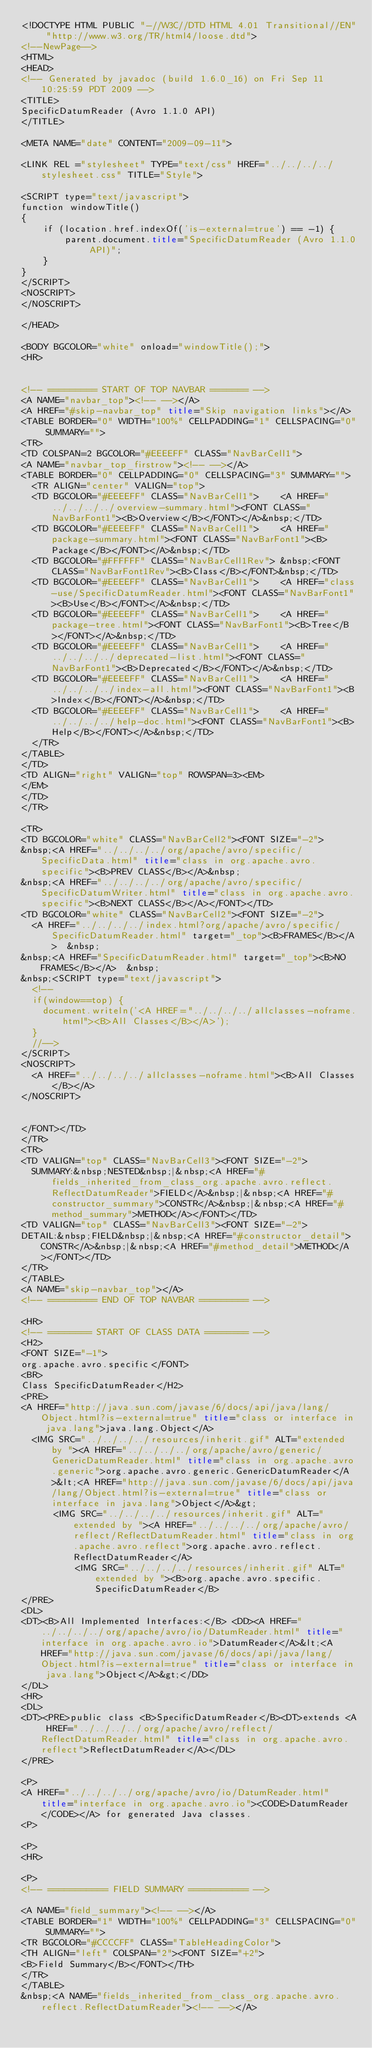<code> <loc_0><loc_0><loc_500><loc_500><_HTML_><!DOCTYPE HTML PUBLIC "-//W3C//DTD HTML 4.01 Transitional//EN" "http://www.w3.org/TR/html4/loose.dtd">
<!--NewPage-->
<HTML>
<HEAD>
<!-- Generated by javadoc (build 1.6.0_16) on Fri Sep 11 10:25:59 PDT 2009 -->
<TITLE>
SpecificDatumReader (Avro 1.1.0 API)
</TITLE>

<META NAME="date" CONTENT="2009-09-11">

<LINK REL ="stylesheet" TYPE="text/css" HREF="../../../../stylesheet.css" TITLE="Style">

<SCRIPT type="text/javascript">
function windowTitle()
{
    if (location.href.indexOf('is-external=true') == -1) {
        parent.document.title="SpecificDatumReader (Avro 1.1.0 API)";
    }
}
</SCRIPT>
<NOSCRIPT>
</NOSCRIPT>

</HEAD>

<BODY BGCOLOR="white" onload="windowTitle();">
<HR>


<!-- ========= START OF TOP NAVBAR ======= -->
<A NAME="navbar_top"><!-- --></A>
<A HREF="#skip-navbar_top" title="Skip navigation links"></A>
<TABLE BORDER="0" WIDTH="100%" CELLPADDING="1" CELLSPACING="0" SUMMARY="">
<TR>
<TD COLSPAN=2 BGCOLOR="#EEEEFF" CLASS="NavBarCell1">
<A NAME="navbar_top_firstrow"><!-- --></A>
<TABLE BORDER="0" CELLPADDING="0" CELLSPACING="3" SUMMARY="">
  <TR ALIGN="center" VALIGN="top">
  <TD BGCOLOR="#EEEEFF" CLASS="NavBarCell1">    <A HREF="../../../../overview-summary.html"><FONT CLASS="NavBarFont1"><B>Overview</B></FONT></A>&nbsp;</TD>
  <TD BGCOLOR="#EEEEFF" CLASS="NavBarCell1">    <A HREF="package-summary.html"><FONT CLASS="NavBarFont1"><B>Package</B></FONT></A>&nbsp;</TD>
  <TD BGCOLOR="#FFFFFF" CLASS="NavBarCell1Rev"> &nbsp;<FONT CLASS="NavBarFont1Rev"><B>Class</B></FONT>&nbsp;</TD>
  <TD BGCOLOR="#EEEEFF" CLASS="NavBarCell1">    <A HREF="class-use/SpecificDatumReader.html"><FONT CLASS="NavBarFont1"><B>Use</B></FONT></A>&nbsp;</TD>
  <TD BGCOLOR="#EEEEFF" CLASS="NavBarCell1">    <A HREF="package-tree.html"><FONT CLASS="NavBarFont1"><B>Tree</B></FONT></A>&nbsp;</TD>
  <TD BGCOLOR="#EEEEFF" CLASS="NavBarCell1">    <A HREF="../../../../deprecated-list.html"><FONT CLASS="NavBarFont1"><B>Deprecated</B></FONT></A>&nbsp;</TD>
  <TD BGCOLOR="#EEEEFF" CLASS="NavBarCell1">    <A HREF="../../../../index-all.html"><FONT CLASS="NavBarFont1"><B>Index</B></FONT></A>&nbsp;</TD>
  <TD BGCOLOR="#EEEEFF" CLASS="NavBarCell1">    <A HREF="../../../../help-doc.html"><FONT CLASS="NavBarFont1"><B>Help</B></FONT></A>&nbsp;</TD>
  </TR>
</TABLE>
</TD>
<TD ALIGN="right" VALIGN="top" ROWSPAN=3><EM>
</EM>
</TD>
</TR>

<TR>
<TD BGCOLOR="white" CLASS="NavBarCell2"><FONT SIZE="-2">
&nbsp;<A HREF="../../../../org/apache/avro/specific/SpecificData.html" title="class in org.apache.avro.specific"><B>PREV CLASS</B></A>&nbsp;
&nbsp;<A HREF="../../../../org/apache/avro/specific/SpecificDatumWriter.html" title="class in org.apache.avro.specific"><B>NEXT CLASS</B></A></FONT></TD>
<TD BGCOLOR="white" CLASS="NavBarCell2"><FONT SIZE="-2">
  <A HREF="../../../../index.html?org/apache/avro/specific/SpecificDatumReader.html" target="_top"><B>FRAMES</B></A>  &nbsp;
&nbsp;<A HREF="SpecificDatumReader.html" target="_top"><B>NO FRAMES</B></A>  &nbsp;
&nbsp;<SCRIPT type="text/javascript">
  <!--
  if(window==top) {
    document.writeln('<A HREF="../../../../allclasses-noframe.html"><B>All Classes</B></A>');
  }
  //-->
</SCRIPT>
<NOSCRIPT>
  <A HREF="../../../../allclasses-noframe.html"><B>All Classes</B></A>
</NOSCRIPT>


</FONT></TD>
</TR>
<TR>
<TD VALIGN="top" CLASS="NavBarCell3"><FONT SIZE="-2">
  SUMMARY:&nbsp;NESTED&nbsp;|&nbsp;<A HREF="#fields_inherited_from_class_org.apache.avro.reflect.ReflectDatumReader">FIELD</A>&nbsp;|&nbsp;<A HREF="#constructor_summary">CONSTR</A>&nbsp;|&nbsp;<A HREF="#method_summary">METHOD</A></FONT></TD>
<TD VALIGN="top" CLASS="NavBarCell3"><FONT SIZE="-2">
DETAIL:&nbsp;FIELD&nbsp;|&nbsp;<A HREF="#constructor_detail">CONSTR</A>&nbsp;|&nbsp;<A HREF="#method_detail">METHOD</A></FONT></TD>
</TR>
</TABLE>
<A NAME="skip-navbar_top"></A>
<!-- ========= END OF TOP NAVBAR ========= -->

<HR>
<!-- ======== START OF CLASS DATA ======== -->
<H2>
<FONT SIZE="-1">
org.apache.avro.specific</FONT>
<BR>
Class SpecificDatumReader</H2>
<PRE>
<A HREF="http://java.sun.com/javase/6/docs/api/java/lang/Object.html?is-external=true" title="class or interface in java.lang">java.lang.Object</A>
  <IMG SRC="../../../../resources/inherit.gif" ALT="extended by "><A HREF="../../../../org/apache/avro/generic/GenericDatumReader.html" title="class in org.apache.avro.generic">org.apache.avro.generic.GenericDatumReader</A>&lt;<A HREF="http://java.sun.com/javase/6/docs/api/java/lang/Object.html?is-external=true" title="class or interface in java.lang">Object</A>&gt;
      <IMG SRC="../../../../resources/inherit.gif" ALT="extended by "><A HREF="../../../../org/apache/avro/reflect/ReflectDatumReader.html" title="class in org.apache.avro.reflect">org.apache.avro.reflect.ReflectDatumReader</A>
          <IMG SRC="../../../../resources/inherit.gif" ALT="extended by "><B>org.apache.avro.specific.SpecificDatumReader</B>
</PRE>
<DL>
<DT><B>All Implemented Interfaces:</B> <DD><A HREF="../../../../org/apache/avro/io/DatumReader.html" title="interface in org.apache.avro.io">DatumReader</A>&lt;<A HREF="http://java.sun.com/javase/6/docs/api/java/lang/Object.html?is-external=true" title="class or interface in java.lang">Object</A>&gt;</DD>
</DL>
<HR>
<DL>
<DT><PRE>public class <B>SpecificDatumReader</B><DT>extends <A HREF="../../../../org/apache/avro/reflect/ReflectDatumReader.html" title="class in org.apache.avro.reflect">ReflectDatumReader</A></DL>
</PRE>

<P>
<A HREF="../../../../org/apache/avro/io/DatumReader.html" title="interface in org.apache.avro.io"><CODE>DatumReader</CODE></A> for generated Java classes.
<P>

<P>
<HR>

<P>
<!-- =========== FIELD SUMMARY =========== -->

<A NAME="field_summary"><!-- --></A>
<TABLE BORDER="1" WIDTH="100%" CELLPADDING="3" CELLSPACING="0" SUMMARY="">
<TR BGCOLOR="#CCCCFF" CLASS="TableHeadingColor">
<TH ALIGN="left" COLSPAN="2"><FONT SIZE="+2">
<B>Field Summary</B></FONT></TH>
</TR>
</TABLE>
&nbsp;<A NAME="fields_inherited_from_class_org.apache.avro.reflect.ReflectDatumReader"><!-- --></A></code> 